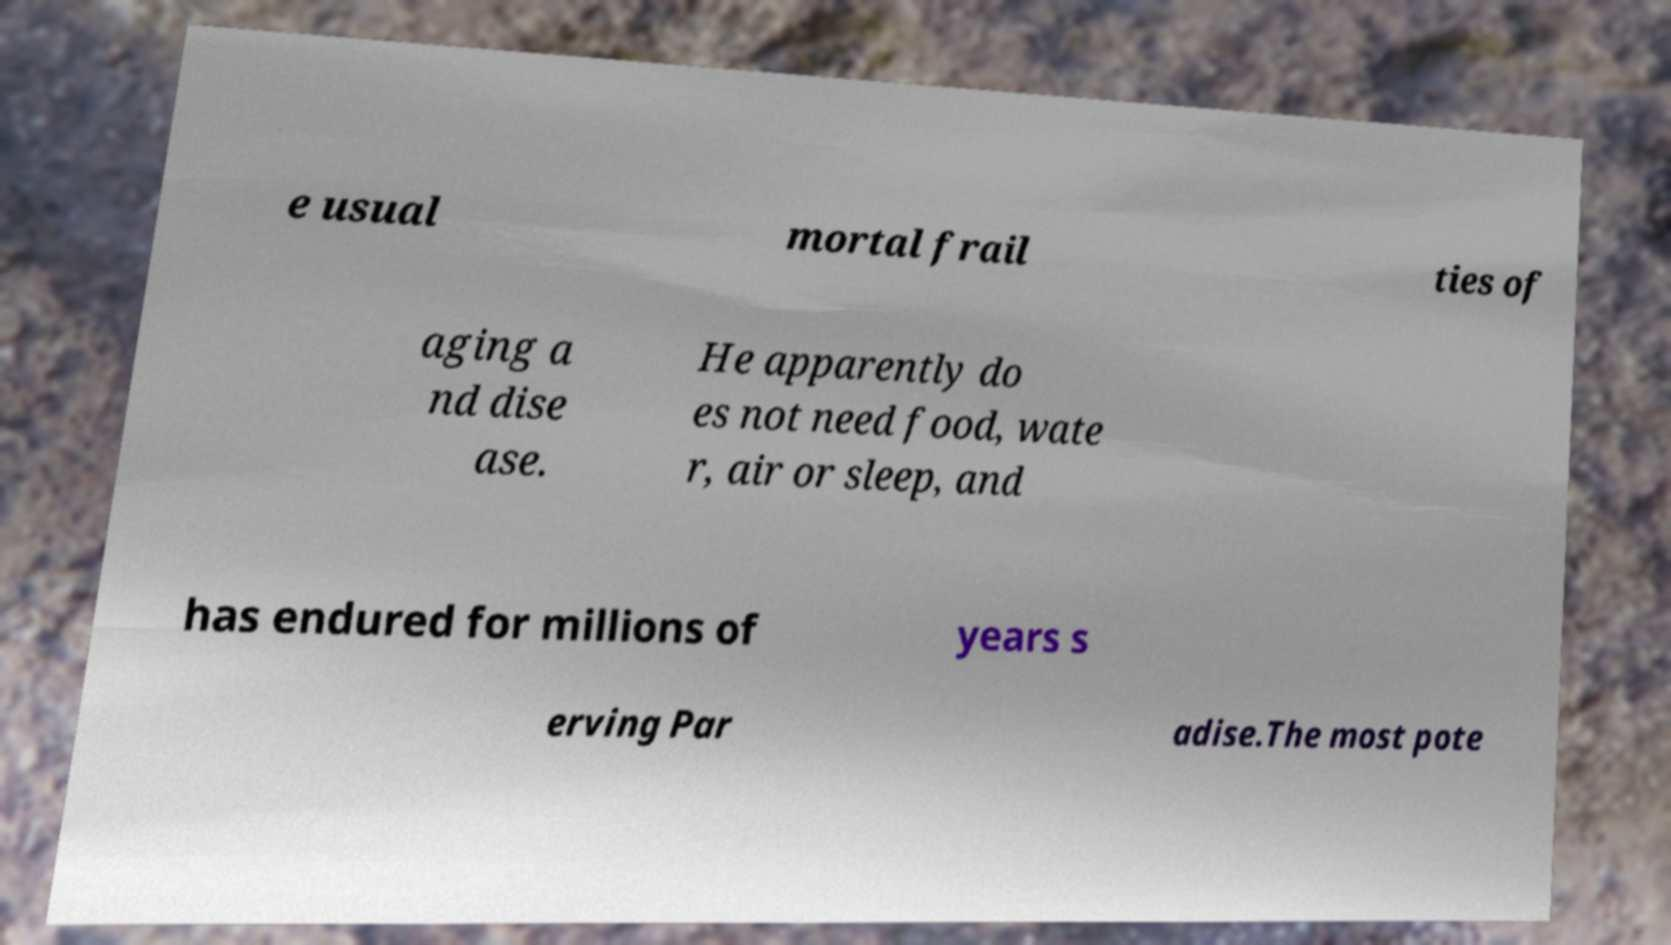Could you extract and type out the text from this image? e usual mortal frail ties of aging a nd dise ase. He apparently do es not need food, wate r, air or sleep, and has endured for millions of years s erving Par adise.The most pote 